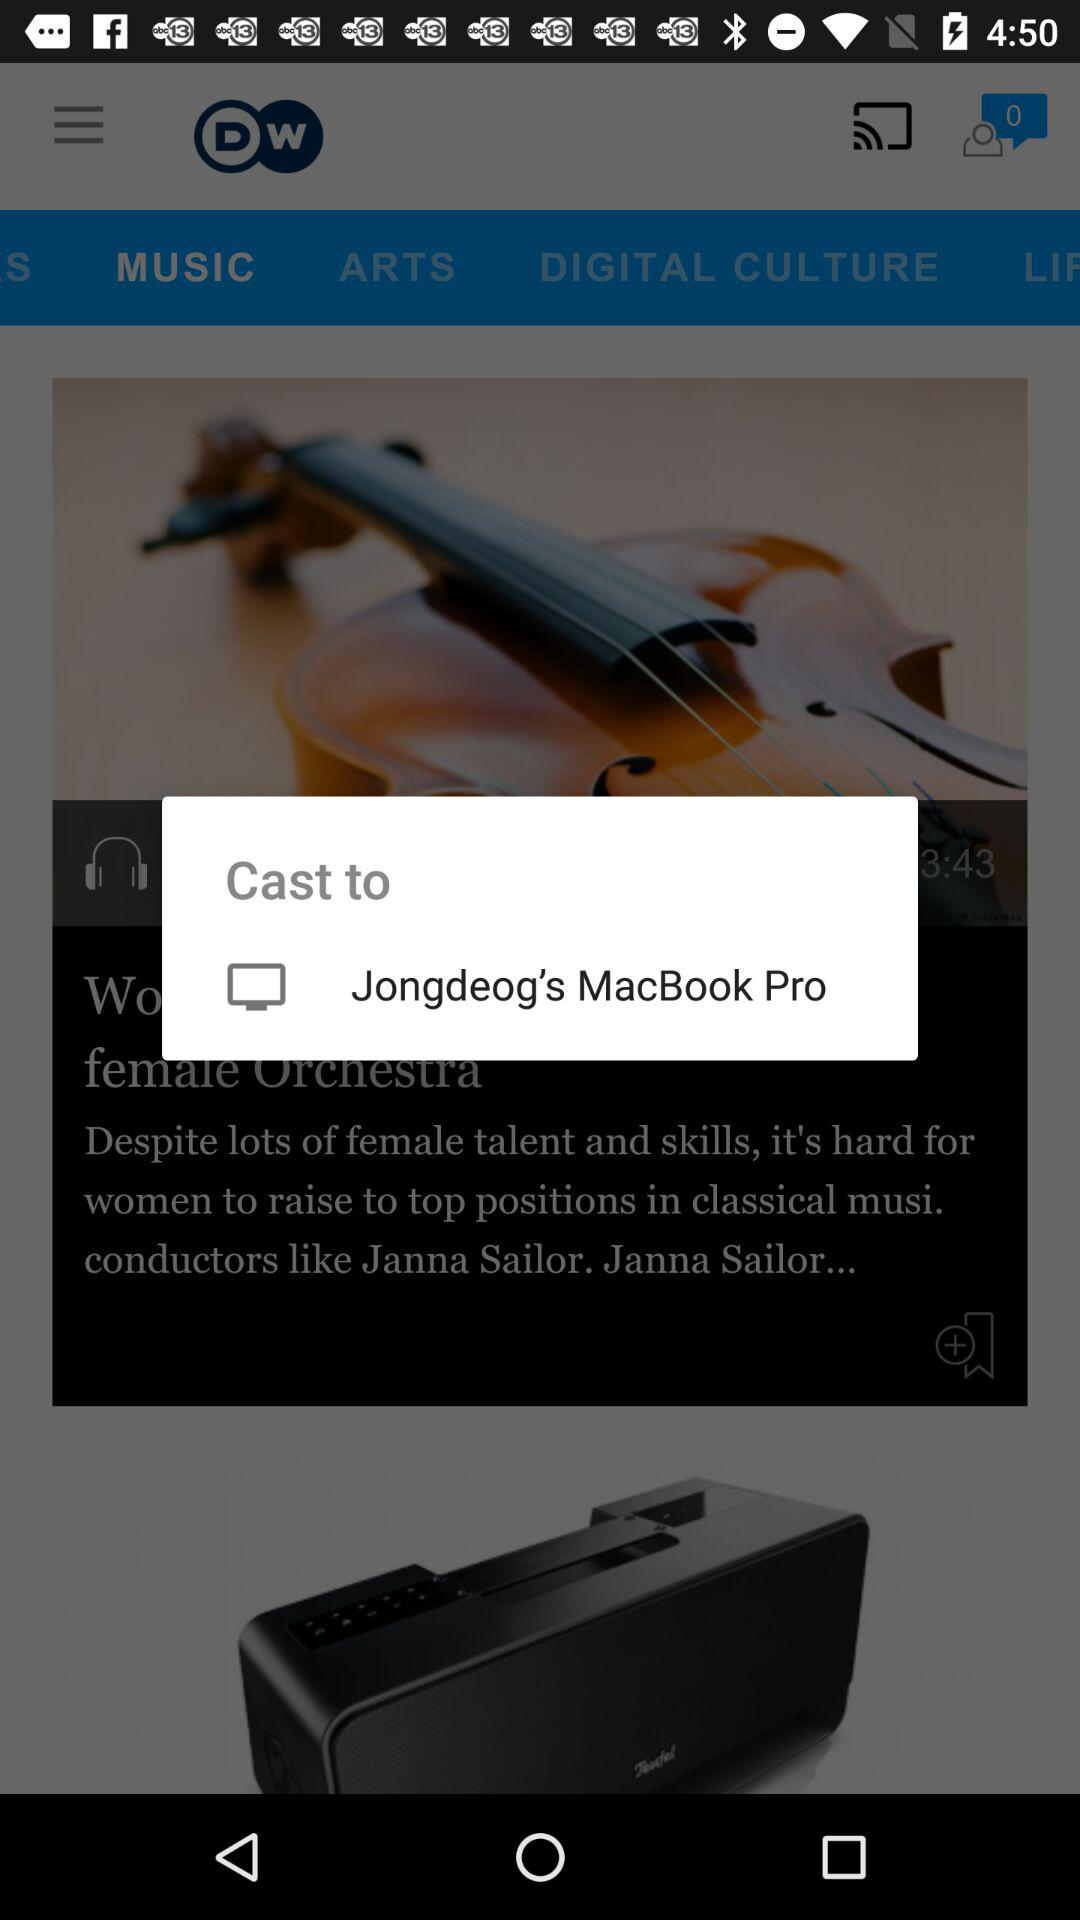Do we have any new messages?
When the provided information is insufficient, respond with <no answer>. <no answer> 